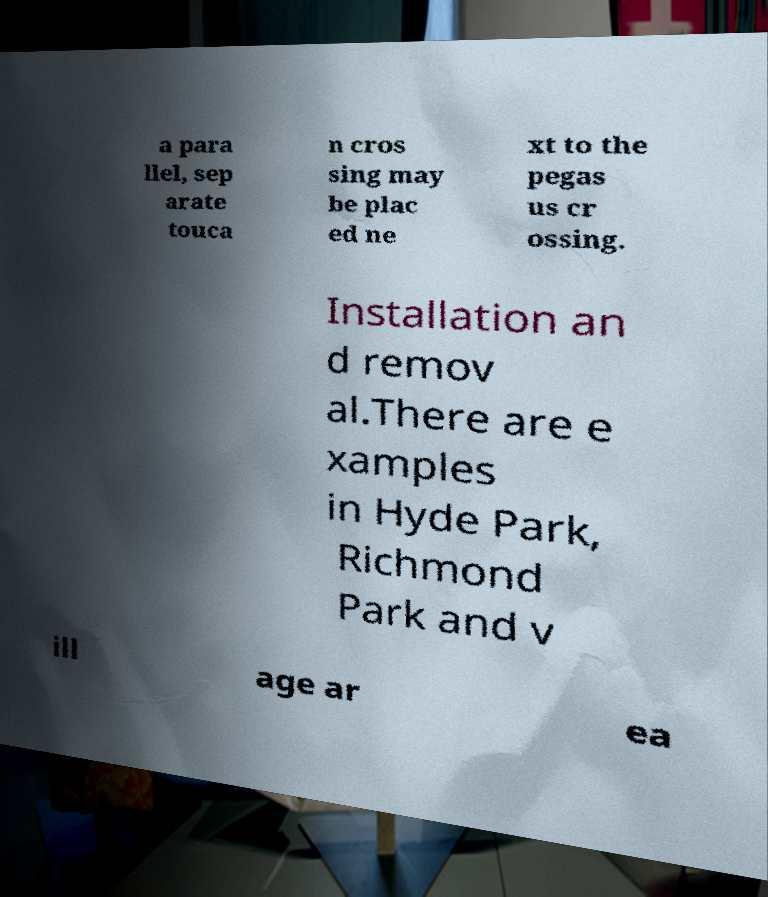Please read and relay the text visible in this image. What does it say? a para llel, sep arate touca n cros sing may be plac ed ne xt to the pegas us cr ossing. Installation an d remov al.There are e xamples in Hyde Park, Richmond Park and v ill age ar ea 